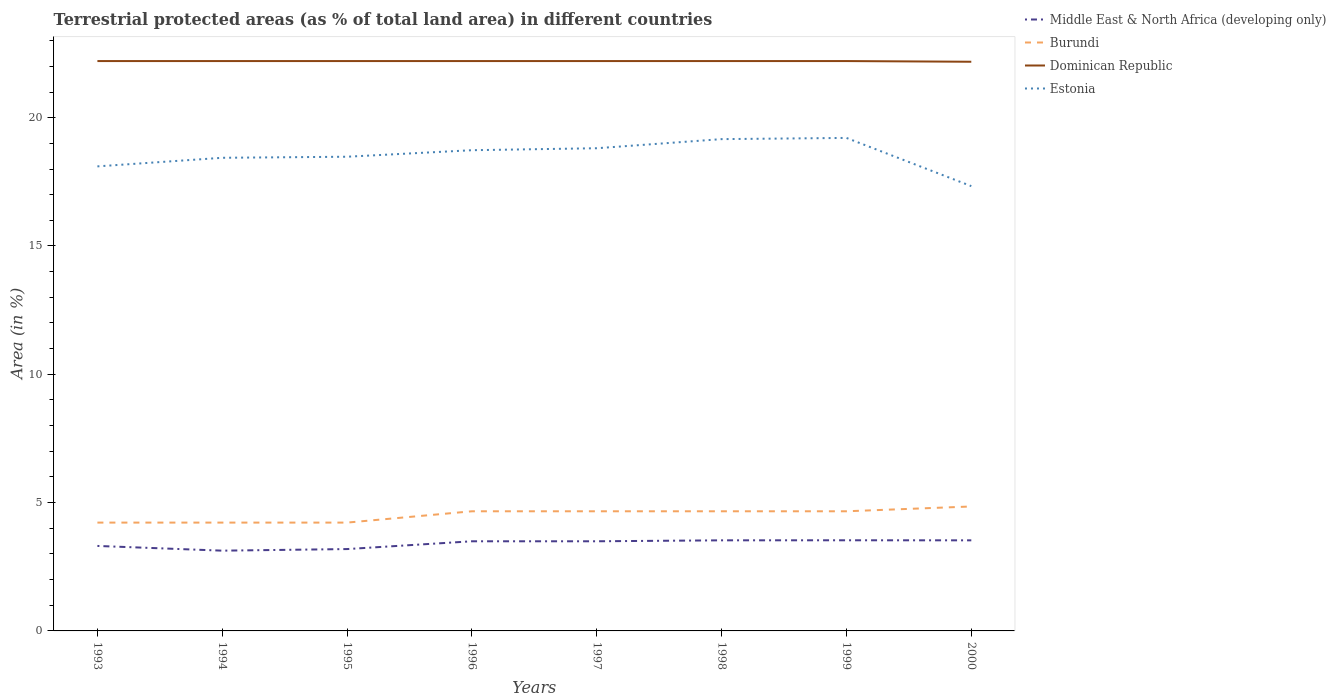How many different coloured lines are there?
Your answer should be compact. 4. Across all years, what is the maximum percentage of terrestrial protected land in Dominican Republic?
Offer a very short reply. 22.18. In which year was the percentage of terrestrial protected land in Dominican Republic maximum?
Ensure brevity in your answer.  2000. What is the total percentage of terrestrial protected land in Estonia in the graph?
Make the answer very short. 0.77. What is the difference between the highest and the second highest percentage of terrestrial protected land in Dominican Republic?
Ensure brevity in your answer.  0.03. What is the difference between the highest and the lowest percentage of terrestrial protected land in Middle East & North Africa (developing only)?
Make the answer very short. 5. How many lines are there?
Keep it short and to the point. 4. What is the difference between two consecutive major ticks on the Y-axis?
Offer a terse response. 5. Does the graph contain any zero values?
Your response must be concise. No. How many legend labels are there?
Keep it short and to the point. 4. What is the title of the graph?
Offer a terse response. Terrestrial protected areas (as % of total land area) in different countries. Does "Romania" appear as one of the legend labels in the graph?
Provide a short and direct response. No. What is the label or title of the Y-axis?
Give a very brief answer. Area (in %). What is the Area (in %) of Middle East & North Africa (developing only) in 1993?
Provide a short and direct response. 3.31. What is the Area (in %) of Burundi in 1993?
Offer a very short reply. 4.22. What is the Area (in %) in Dominican Republic in 1993?
Keep it short and to the point. 22.21. What is the Area (in %) in Estonia in 1993?
Offer a terse response. 18.1. What is the Area (in %) in Middle East & North Africa (developing only) in 1994?
Ensure brevity in your answer.  3.13. What is the Area (in %) in Burundi in 1994?
Your answer should be very brief. 4.22. What is the Area (in %) of Dominican Republic in 1994?
Your response must be concise. 22.21. What is the Area (in %) in Estonia in 1994?
Provide a succinct answer. 18.44. What is the Area (in %) of Middle East & North Africa (developing only) in 1995?
Your answer should be very brief. 3.19. What is the Area (in %) in Burundi in 1995?
Ensure brevity in your answer.  4.22. What is the Area (in %) in Dominican Republic in 1995?
Your answer should be compact. 22.21. What is the Area (in %) in Estonia in 1995?
Keep it short and to the point. 18.48. What is the Area (in %) of Middle East & North Africa (developing only) in 1996?
Give a very brief answer. 3.49. What is the Area (in %) of Burundi in 1996?
Your answer should be very brief. 4.66. What is the Area (in %) in Dominican Republic in 1996?
Provide a short and direct response. 22.21. What is the Area (in %) in Estonia in 1996?
Offer a very short reply. 18.73. What is the Area (in %) of Middle East & North Africa (developing only) in 1997?
Offer a very short reply. 3.49. What is the Area (in %) in Burundi in 1997?
Provide a short and direct response. 4.66. What is the Area (in %) in Dominican Republic in 1997?
Give a very brief answer. 22.21. What is the Area (in %) in Estonia in 1997?
Your answer should be very brief. 18.81. What is the Area (in %) of Middle East & North Africa (developing only) in 1998?
Offer a terse response. 3.53. What is the Area (in %) in Burundi in 1998?
Your answer should be very brief. 4.66. What is the Area (in %) in Dominican Republic in 1998?
Your response must be concise. 22.21. What is the Area (in %) of Estonia in 1998?
Ensure brevity in your answer.  19.16. What is the Area (in %) of Middle East & North Africa (developing only) in 1999?
Make the answer very short. 3.53. What is the Area (in %) in Burundi in 1999?
Offer a terse response. 4.66. What is the Area (in %) of Dominican Republic in 1999?
Provide a succinct answer. 22.21. What is the Area (in %) in Estonia in 1999?
Provide a short and direct response. 19.21. What is the Area (in %) in Middle East & North Africa (developing only) in 2000?
Provide a short and direct response. 3.53. What is the Area (in %) of Burundi in 2000?
Give a very brief answer. 4.85. What is the Area (in %) in Dominican Republic in 2000?
Make the answer very short. 22.18. What is the Area (in %) of Estonia in 2000?
Your answer should be compact. 17.33. Across all years, what is the maximum Area (in %) in Middle East & North Africa (developing only)?
Keep it short and to the point. 3.53. Across all years, what is the maximum Area (in %) in Burundi?
Give a very brief answer. 4.85. Across all years, what is the maximum Area (in %) of Dominican Republic?
Make the answer very short. 22.21. Across all years, what is the maximum Area (in %) in Estonia?
Your answer should be very brief. 19.21. Across all years, what is the minimum Area (in %) of Middle East & North Africa (developing only)?
Make the answer very short. 3.13. Across all years, what is the minimum Area (in %) of Burundi?
Offer a very short reply. 4.22. Across all years, what is the minimum Area (in %) in Dominican Republic?
Ensure brevity in your answer.  22.18. Across all years, what is the minimum Area (in %) in Estonia?
Your response must be concise. 17.33. What is the total Area (in %) in Middle East & North Africa (developing only) in the graph?
Your response must be concise. 27.21. What is the total Area (in %) in Burundi in the graph?
Make the answer very short. 36.16. What is the total Area (in %) of Dominican Republic in the graph?
Your answer should be compact. 177.63. What is the total Area (in %) of Estonia in the graph?
Ensure brevity in your answer.  148.27. What is the difference between the Area (in %) of Middle East & North Africa (developing only) in 1993 and that in 1994?
Your answer should be compact. 0.18. What is the difference between the Area (in %) of Burundi in 1993 and that in 1994?
Your response must be concise. 0. What is the difference between the Area (in %) of Dominican Republic in 1993 and that in 1994?
Make the answer very short. 0. What is the difference between the Area (in %) of Estonia in 1993 and that in 1994?
Ensure brevity in your answer.  -0.34. What is the difference between the Area (in %) of Middle East & North Africa (developing only) in 1993 and that in 1995?
Your answer should be very brief. 0.12. What is the difference between the Area (in %) of Estonia in 1993 and that in 1995?
Provide a succinct answer. -0.38. What is the difference between the Area (in %) of Middle East & North Africa (developing only) in 1993 and that in 1996?
Offer a very short reply. -0.18. What is the difference between the Area (in %) in Burundi in 1993 and that in 1996?
Your answer should be compact. -0.44. What is the difference between the Area (in %) in Estonia in 1993 and that in 1996?
Offer a terse response. -0.63. What is the difference between the Area (in %) in Middle East & North Africa (developing only) in 1993 and that in 1997?
Provide a short and direct response. -0.18. What is the difference between the Area (in %) of Burundi in 1993 and that in 1997?
Keep it short and to the point. -0.44. What is the difference between the Area (in %) in Estonia in 1993 and that in 1997?
Your response must be concise. -0.71. What is the difference between the Area (in %) in Middle East & North Africa (developing only) in 1993 and that in 1998?
Make the answer very short. -0.22. What is the difference between the Area (in %) of Burundi in 1993 and that in 1998?
Give a very brief answer. -0.44. What is the difference between the Area (in %) of Estonia in 1993 and that in 1998?
Provide a short and direct response. -1.06. What is the difference between the Area (in %) of Middle East & North Africa (developing only) in 1993 and that in 1999?
Keep it short and to the point. -0.22. What is the difference between the Area (in %) in Burundi in 1993 and that in 1999?
Your answer should be very brief. -0.44. What is the difference between the Area (in %) in Dominican Republic in 1993 and that in 1999?
Keep it short and to the point. 0. What is the difference between the Area (in %) in Estonia in 1993 and that in 1999?
Offer a very short reply. -1.11. What is the difference between the Area (in %) of Middle East & North Africa (developing only) in 1993 and that in 2000?
Make the answer very short. -0.22. What is the difference between the Area (in %) in Burundi in 1993 and that in 2000?
Keep it short and to the point. -0.63. What is the difference between the Area (in %) of Dominican Republic in 1993 and that in 2000?
Your answer should be very brief. 0.03. What is the difference between the Area (in %) in Estonia in 1993 and that in 2000?
Provide a short and direct response. 0.77. What is the difference between the Area (in %) in Middle East & North Africa (developing only) in 1994 and that in 1995?
Make the answer very short. -0.06. What is the difference between the Area (in %) in Burundi in 1994 and that in 1995?
Make the answer very short. 0. What is the difference between the Area (in %) in Dominican Republic in 1994 and that in 1995?
Your response must be concise. 0. What is the difference between the Area (in %) in Estonia in 1994 and that in 1995?
Your response must be concise. -0.04. What is the difference between the Area (in %) in Middle East & North Africa (developing only) in 1994 and that in 1996?
Keep it short and to the point. -0.37. What is the difference between the Area (in %) of Burundi in 1994 and that in 1996?
Your answer should be compact. -0.44. What is the difference between the Area (in %) in Dominican Republic in 1994 and that in 1996?
Give a very brief answer. 0. What is the difference between the Area (in %) in Estonia in 1994 and that in 1996?
Make the answer very short. -0.3. What is the difference between the Area (in %) of Middle East & North Africa (developing only) in 1994 and that in 1997?
Offer a terse response. -0.37. What is the difference between the Area (in %) in Burundi in 1994 and that in 1997?
Your answer should be very brief. -0.44. What is the difference between the Area (in %) in Estonia in 1994 and that in 1997?
Make the answer very short. -0.37. What is the difference between the Area (in %) of Middle East & North Africa (developing only) in 1994 and that in 1998?
Offer a terse response. -0.4. What is the difference between the Area (in %) of Burundi in 1994 and that in 1998?
Provide a succinct answer. -0.44. What is the difference between the Area (in %) in Dominican Republic in 1994 and that in 1998?
Keep it short and to the point. 0. What is the difference between the Area (in %) in Estonia in 1994 and that in 1998?
Offer a terse response. -0.73. What is the difference between the Area (in %) of Middle East & North Africa (developing only) in 1994 and that in 1999?
Make the answer very short. -0.4. What is the difference between the Area (in %) in Burundi in 1994 and that in 1999?
Your answer should be compact. -0.44. What is the difference between the Area (in %) in Estonia in 1994 and that in 1999?
Keep it short and to the point. -0.77. What is the difference between the Area (in %) of Middle East & North Africa (developing only) in 1994 and that in 2000?
Provide a succinct answer. -0.4. What is the difference between the Area (in %) in Burundi in 1994 and that in 2000?
Give a very brief answer. -0.63. What is the difference between the Area (in %) in Dominican Republic in 1994 and that in 2000?
Keep it short and to the point. 0.03. What is the difference between the Area (in %) in Estonia in 1994 and that in 2000?
Keep it short and to the point. 1.1. What is the difference between the Area (in %) of Middle East & North Africa (developing only) in 1995 and that in 1996?
Your response must be concise. -0.3. What is the difference between the Area (in %) in Burundi in 1995 and that in 1996?
Your response must be concise. -0.44. What is the difference between the Area (in %) of Dominican Republic in 1995 and that in 1996?
Give a very brief answer. 0. What is the difference between the Area (in %) in Estonia in 1995 and that in 1996?
Offer a very short reply. -0.25. What is the difference between the Area (in %) of Middle East & North Africa (developing only) in 1995 and that in 1997?
Your answer should be compact. -0.3. What is the difference between the Area (in %) of Burundi in 1995 and that in 1997?
Give a very brief answer. -0.44. What is the difference between the Area (in %) of Dominican Republic in 1995 and that in 1997?
Your response must be concise. 0. What is the difference between the Area (in %) in Estonia in 1995 and that in 1997?
Provide a succinct answer. -0.33. What is the difference between the Area (in %) in Middle East & North Africa (developing only) in 1995 and that in 1998?
Make the answer very short. -0.34. What is the difference between the Area (in %) in Burundi in 1995 and that in 1998?
Give a very brief answer. -0.44. What is the difference between the Area (in %) of Estonia in 1995 and that in 1998?
Your answer should be very brief. -0.69. What is the difference between the Area (in %) of Middle East & North Africa (developing only) in 1995 and that in 1999?
Your answer should be very brief. -0.34. What is the difference between the Area (in %) in Burundi in 1995 and that in 1999?
Your answer should be very brief. -0.44. What is the difference between the Area (in %) of Estonia in 1995 and that in 1999?
Your answer should be very brief. -0.73. What is the difference between the Area (in %) of Middle East & North Africa (developing only) in 1995 and that in 2000?
Keep it short and to the point. -0.34. What is the difference between the Area (in %) in Burundi in 1995 and that in 2000?
Keep it short and to the point. -0.63. What is the difference between the Area (in %) of Dominican Republic in 1995 and that in 2000?
Make the answer very short. 0.03. What is the difference between the Area (in %) of Estonia in 1995 and that in 2000?
Ensure brevity in your answer.  1.15. What is the difference between the Area (in %) of Middle East & North Africa (developing only) in 1996 and that in 1997?
Your response must be concise. -0. What is the difference between the Area (in %) in Estonia in 1996 and that in 1997?
Ensure brevity in your answer.  -0.08. What is the difference between the Area (in %) of Middle East & North Africa (developing only) in 1996 and that in 1998?
Make the answer very short. -0.04. What is the difference between the Area (in %) in Estonia in 1996 and that in 1998?
Give a very brief answer. -0.43. What is the difference between the Area (in %) in Middle East & North Africa (developing only) in 1996 and that in 1999?
Provide a short and direct response. -0.04. What is the difference between the Area (in %) in Burundi in 1996 and that in 1999?
Keep it short and to the point. 0. What is the difference between the Area (in %) of Estonia in 1996 and that in 1999?
Keep it short and to the point. -0.48. What is the difference between the Area (in %) of Middle East & North Africa (developing only) in 1996 and that in 2000?
Keep it short and to the point. -0.04. What is the difference between the Area (in %) of Burundi in 1996 and that in 2000?
Provide a short and direct response. -0.19. What is the difference between the Area (in %) of Dominican Republic in 1996 and that in 2000?
Give a very brief answer. 0.03. What is the difference between the Area (in %) of Middle East & North Africa (developing only) in 1997 and that in 1998?
Your response must be concise. -0.04. What is the difference between the Area (in %) of Estonia in 1997 and that in 1998?
Give a very brief answer. -0.35. What is the difference between the Area (in %) in Middle East & North Africa (developing only) in 1997 and that in 1999?
Offer a terse response. -0.04. What is the difference between the Area (in %) of Burundi in 1997 and that in 1999?
Your answer should be very brief. 0. What is the difference between the Area (in %) in Estonia in 1997 and that in 1999?
Your answer should be compact. -0.4. What is the difference between the Area (in %) in Middle East & North Africa (developing only) in 1997 and that in 2000?
Provide a succinct answer. -0.04. What is the difference between the Area (in %) in Burundi in 1997 and that in 2000?
Ensure brevity in your answer.  -0.19. What is the difference between the Area (in %) in Dominican Republic in 1997 and that in 2000?
Ensure brevity in your answer.  0.03. What is the difference between the Area (in %) in Estonia in 1997 and that in 2000?
Ensure brevity in your answer.  1.48. What is the difference between the Area (in %) of Middle East & North Africa (developing only) in 1998 and that in 1999?
Keep it short and to the point. -0. What is the difference between the Area (in %) of Dominican Republic in 1998 and that in 1999?
Your answer should be very brief. 0. What is the difference between the Area (in %) of Estonia in 1998 and that in 1999?
Offer a very short reply. -0.05. What is the difference between the Area (in %) of Middle East & North Africa (developing only) in 1998 and that in 2000?
Provide a short and direct response. 0. What is the difference between the Area (in %) in Burundi in 1998 and that in 2000?
Provide a succinct answer. -0.19. What is the difference between the Area (in %) in Dominican Republic in 1998 and that in 2000?
Give a very brief answer. 0.03. What is the difference between the Area (in %) in Estonia in 1998 and that in 2000?
Provide a succinct answer. 1.83. What is the difference between the Area (in %) of Middle East & North Africa (developing only) in 1999 and that in 2000?
Your answer should be very brief. 0. What is the difference between the Area (in %) of Burundi in 1999 and that in 2000?
Ensure brevity in your answer.  -0.19. What is the difference between the Area (in %) in Dominican Republic in 1999 and that in 2000?
Give a very brief answer. 0.03. What is the difference between the Area (in %) in Estonia in 1999 and that in 2000?
Provide a succinct answer. 1.88. What is the difference between the Area (in %) of Middle East & North Africa (developing only) in 1993 and the Area (in %) of Burundi in 1994?
Ensure brevity in your answer.  -0.91. What is the difference between the Area (in %) of Middle East & North Africa (developing only) in 1993 and the Area (in %) of Dominican Republic in 1994?
Give a very brief answer. -18.89. What is the difference between the Area (in %) in Middle East & North Africa (developing only) in 1993 and the Area (in %) in Estonia in 1994?
Provide a succinct answer. -15.13. What is the difference between the Area (in %) of Burundi in 1993 and the Area (in %) of Dominican Republic in 1994?
Ensure brevity in your answer.  -17.99. What is the difference between the Area (in %) of Burundi in 1993 and the Area (in %) of Estonia in 1994?
Your answer should be very brief. -14.22. What is the difference between the Area (in %) of Dominican Republic in 1993 and the Area (in %) of Estonia in 1994?
Provide a short and direct response. 3.77. What is the difference between the Area (in %) of Middle East & North Africa (developing only) in 1993 and the Area (in %) of Burundi in 1995?
Ensure brevity in your answer.  -0.91. What is the difference between the Area (in %) of Middle East & North Africa (developing only) in 1993 and the Area (in %) of Dominican Republic in 1995?
Give a very brief answer. -18.89. What is the difference between the Area (in %) of Middle East & North Africa (developing only) in 1993 and the Area (in %) of Estonia in 1995?
Offer a very short reply. -15.17. What is the difference between the Area (in %) of Burundi in 1993 and the Area (in %) of Dominican Republic in 1995?
Make the answer very short. -17.99. What is the difference between the Area (in %) of Burundi in 1993 and the Area (in %) of Estonia in 1995?
Provide a short and direct response. -14.26. What is the difference between the Area (in %) in Dominican Republic in 1993 and the Area (in %) in Estonia in 1995?
Make the answer very short. 3.73. What is the difference between the Area (in %) of Middle East & North Africa (developing only) in 1993 and the Area (in %) of Burundi in 1996?
Your answer should be very brief. -1.35. What is the difference between the Area (in %) in Middle East & North Africa (developing only) in 1993 and the Area (in %) in Dominican Republic in 1996?
Provide a succinct answer. -18.89. What is the difference between the Area (in %) in Middle East & North Africa (developing only) in 1993 and the Area (in %) in Estonia in 1996?
Offer a terse response. -15.42. What is the difference between the Area (in %) of Burundi in 1993 and the Area (in %) of Dominican Republic in 1996?
Keep it short and to the point. -17.99. What is the difference between the Area (in %) of Burundi in 1993 and the Area (in %) of Estonia in 1996?
Your answer should be compact. -14.51. What is the difference between the Area (in %) in Dominican Republic in 1993 and the Area (in %) in Estonia in 1996?
Offer a very short reply. 3.47. What is the difference between the Area (in %) in Middle East & North Africa (developing only) in 1993 and the Area (in %) in Burundi in 1997?
Provide a succinct answer. -1.35. What is the difference between the Area (in %) of Middle East & North Africa (developing only) in 1993 and the Area (in %) of Dominican Republic in 1997?
Provide a short and direct response. -18.89. What is the difference between the Area (in %) in Middle East & North Africa (developing only) in 1993 and the Area (in %) in Estonia in 1997?
Make the answer very short. -15.5. What is the difference between the Area (in %) of Burundi in 1993 and the Area (in %) of Dominican Republic in 1997?
Give a very brief answer. -17.99. What is the difference between the Area (in %) of Burundi in 1993 and the Area (in %) of Estonia in 1997?
Make the answer very short. -14.59. What is the difference between the Area (in %) of Dominican Republic in 1993 and the Area (in %) of Estonia in 1997?
Your answer should be very brief. 3.4. What is the difference between the Area (in %) of Middle East & North Africa (developing only) in 1993 and the Area (in %) of Burundi in 1998?
Provide a short and direct response. -1.35. What is the difference between the Area (in %) in Middle East & North Africa (developing only) in 1993 and the Area (in %) in Dominican Republic in 1998?
Your response must be concise. -18.89. What is the difference between the Area (in %) in Middle East & North Africa (developing only) in 1993 and the Area (in %) in Estonia in 1998?
Offer a terse response. -15.85. What is the difference between the Area (in %) of Burundi in 1993 and the Area (in %) of Dominican Republic in 1998?
Offer a terse response. -17.99. What is the difference between the Area (in %) in Burundi in 1993 and the Area (in %) in Estonia in 1998?
Your answer should be compact. -14.94. What is the difference between the Area (in %) in Dominican Republic in 1993 and the Area (in %) in Estonia in 1998?
Give a very brief answer. 3.04. What is the difference between the Area (in %) in Middle East & North Africa (developing only) in 1993 and the Area (in %) in Burundi in 1999?
Your answer should be compact. -1.35. What is the difference between the Area (in %) of Middle East & North Africa (developing only) in 1993 and the Area (in %) of Dominican Republic in 1999?
Your answer should be very brief. -18.89. What is the difference between the Area (in %) of Middle East & North Africa (developing only) in 1993 and the Area (in %) of Estonia in 1999?
Make the answer very short. -15.9. What is the difference between the Area (in %) of Burundi in 1993 and the Area (in %) of Dominican Republic in 1999?
Give a very brief answer. -17.99. What is the difference between the Area (in %) in Burundi in 1993 and the Area (in %) in Estonia in 1999?
Offer a very short reply. -14.99. What is the difference between the Area (in %) of Dominican Republic in 1993 and the Area (in %) of Estonia in 1999?
Offer a terse response. 3. What is the difference between the Area (in %) of Middle East & North Africa (developing only) in 1993 and the Area (in %) of Burundi in 2000?
Your answer should be compact. -1.54. What is the difference between the Area (in %) in Middle East & North Africa (developing only) in 1993 and the Area (in %) in Dominican Republic in 2000?
Offer a very short reply. -18.87. What is the difference between the Area (in %) in Middle East & North Africa (developing only) in 1993 and the Area (in %) in Estonia in 2000?
Provide a short and direct response. -14.02. What is the difference between the Area (in %) in Burundi in 1993 and the Area (in %) in Dominican Republic in 2000?
Ensure brevity in your answer.  -17.96. What is the difference between the Area (in %) of Burundi in 1993 and the Area (in %) of Estonia in 2000?
Provide a succinct answer. -13.11. What is the difference between the Area (in %) of Dominican Republic in 1993 and the Area (in %) of Estonia in 2000?
Ensure brevity in your answer.  4.87. What is the difference between the Area (in %) in Middle East & North Africa (developing only) in 1994 and the Area (in %) in Burundi in 1995?
Give a very brief answer. -1.09. What is the difference between the Area (in %) in Middle East & North Africa (developing only) in 1994 and the Area (in %) in Dominican Republic in 1995?
Your answer should be very brief. -19.08. What is the difference between the Area (in %) of Middle East & North Africa (developing only) in 1994 and the Area (in %) of Estonia in 1995?
Give a very brief answer. -15.35. What is the difference between the Area (in %) in Burundi in 1994 and the Area (in %) in Dominican Republic in 1995?
Your response must be concise. -17.99. What is the difference between the Area (in %) of Burundi in 1994 and the Area (in %) of Estonia in 1995?
Keep it short and to the point. -14.26. What is the difference between the Area (in %) in Dominican Republic in 1994 and the Area (in %) in Estonia in 1995?
Your answer should be compact. 3.73. What is the difference between the Area (in %) in Middle East & North Africa (developing only) in 1994 and the Area (in %) in Burundi in 1996?
Ensure brevity in your answer.  -1.53. What is the difference between the Area (in %) in Middle East & North Africa (developing only) in 1994 and the Area (in %) in Dominican Republic in 1996?
Your answer should be very brief. -19.08. What is the difference between the Area (in %) in Middle East & North Africa (developing only) in 1994 and the Area (in %) in Estonia in 1996?
Your response must be concise. -15.6. What is the difference between the Area (in %) of Burundi in 1994 and the Area (in %) of Dominican Republic in 1996?
Offer a very short reply. -17.99. What is the difference between the Area (in %) in Burundi in 1994 and the Area (in %) in Estonia in 1996?
Give a very brief answer. -14.51. What is the difference between the Area (in %) in Dominican Republic in 1994 and the Area (in %) in Estonia in 1996?
Offer a very short reply. 3.47. What is the difference between the Area (in %) of Middle East & North Africa (developing only) in 1994 and the Area (in %) of Burundi in 1997?
Ensure brevity in your answer.  -1.53. What is the difference between the Area (in %) of Middle East & North Africa (developing only) in 1994 and the Area (in %) of Dominican Republic in 1997?
Your answer should be very brief. -19.08. What is the difference between the Area (in %) in Middle East & North Africa (developing only) in 1994 and the Area (in %) in Estonia in 1997?
Offer a terse response. -15.68. What is the difference between the Area (in %) in Burundi in 1994 and the Area (in %) in Dominican Republic in 1997?
Your answer should be compact. -17.99. What is the difference between the Area (in %) in Burundi in 1994 and the Area (in %) in Estonia in 1997?
Offer a terse response. -14.59. What is the difference between the Area (in %) of Dominican Republic in 1994 and the Area (in %) of Estonia in 1997?
Keep it short and to the point. 3.4. What is the difference between the Area (in %) in Middle East & North Africa (developing only) in 1994 and the Area (in %) in Burundi in 1998?
Make the answer very short. -1.53. What is the difference between the Area (in %) in Middle East & North Africa (developing only) in 1994 and the Area (in %) in Dominican Republic in 1998?
Give a very brief answer. -19.08. What is the difference between the Area (in %) in Middle East & North Africa (developing only) in 1994 and the Area (in %) in Estonia in 1998?
Provide a short and direct response. -16.04. What is the difference between the Area (in %) in Burundi in 1994 and the Area (in %) in Dominican Republic in 1998?
Ensure brevity in your answer.  -17.99. What is the difference between the Area (in %) in Burundi in 1994 and the Area (in %) in Estonia in 1998?
Your answer should be very brief. -14.94. What is the difference between the Area (in %) in Dominican Republic in 1994 and the Area (in %) in Estonia in 1998?
Keep it short and to the point. 3.04. What is the difference between the Area (in %) of Middle East & North Africa (developing only) in 1994 and the Area (in %) of Burundi in 1999?
Give a very brief answer. -1.53. What is the difference between the Area (in %) in Middle East & North Africa (developing only) in 1994 and the Area (in %) in Dominican Republic in 1999?
Give a very brief answer. -19.08. What is the difference between the Area (in %) in Middle East & North Africa (developing only) in 1994 and the Area (in %) in Estonia in 1999?
Offer a terse response. -16.08. What is the difference between the Area (in %) of Burundi in 1994 and the Area (in %) of Dominican Republic in 1999?
Provide a short and direct response. -17.99. What is the difference between the Area (in %) in Burundi in 1994 and the Area (in %) in Estonia in 1999?
Your response must be concise. -14.99. What is the difference between the Area (in %) in Dominican Republic in 1994 and the Area (in %) in Estonia in 1999?
Offer a very short reply. 3. What is the difference between the Area (in %) of Middle East & North Africa (developing only) in 1994 and the Area (in %) of Burundi in 2000?
Your answer should be compact. -1.72. What is the difference between the Area (in %) of Middle East & North Africa (developing only) in 1994 and the Area (in %) of Dominican Republic in 2000?
Your answer should be very brief. -19.05. What is the difference between the Area (in %) in Middle East & North Africa (developing only) in 1994 and the Area (in %) in Estonia in 2000?
Give a very brief answer. -14.21. What is the difference between the Area (in %) in Burundi in 1994 and the Area (in %) in Dominican Republic in 2000?
Your response must be concise. -17.96. What is the difference between the Area (in %) of Burundi in 1994 and the Area (in %) of Estonia in 2000?
Provide a succinct answer. -13.11. What is the difference between the Area (in %) of Dominican Republic in 1994 and the Area (in %) of Estonia in 2000?
Give a very brief answer. 4.87. What is the difference between the Area (in %) of Middle East & North Africa (developing only) in 1995 and the Area (in %) of Burundi in 1996?
Offer a very short reply. -1.47. What is the difference between the Area (in %) of Middle East & North Africa (developing only) in 1995 and the Area (in %) of Dominican Republic in 1996?
Make the answer very short. -19.02. What is the difference between the Area (in %) of Middle East & North Africa (developing only) in 1995 and the Area (in %) of Estonia in 1996?
Make the answer very short. -15.54. What is the difference between the Area (in %) in Burundi in 1995 and the Area (in %) in Dominican Republic in 1996?
Your answer should be very brief. -17.99. What is the difference between the Area (in %) of Burundi in 1995 and the Area (in %) of Estonia in 1996?
Your response must be concise. -14.51. What is the difference between the Area (in %) of Dominican Republic in 1995 and the Area (in %) of Estonia in 1996?
Make the answer very short. 3.47. What is the difference between the Area (in %) in Middle East & North Africa (developing only) in 1995 and the Area (in %) in Burundi in 1997?
Provide a succinct answer. -1.47. What is the difference between the Area (in %) of Middle East & North Africa (developing only) in 1995 and the Area (in %) of Dominican Republic in 1997?
Keep it short and to the point. -19.02. What is the difference between the Area (in %) of Middle East & North Africa (developing only) in 1995 and the Area (in %) of Estonia in 1997?
Your response must be concise. -15.62. What is the difference between the Area (in %) of Burundi in 1995 and the Area (in %) of Dominican Republic in 1997?
Your answer should be very brief. -17.99. What is the difference between the Area (in %) of Burundi in 1995 and the Area (in %) of Estonia in 1997?
Give a very brief answer. -14.59. What is the difference between the Area (in %) of Dominican Republic in 1995 and the Area (in %) of Estonia in 1997?
Give a very brief answer. 3.4. What is the difference between the Area (in %) of Middle East & North Africa (developing only) in 1995 and the Area (in %) of Burundi in 1998?
Provide a short and direct response. -1.47. What is the difference between the Area (in %) in Middle East & North Africa (developing only) in 1995 and the Area (in %) in Dominican Republic in 1998?
Provide a short and direct response. -19.02. What is the difference between the Area (in %) in Middle East & North Africa (developing only) in 1995 and the Area (in %) in Estonia in 1998?
Your answer should be very brief. -15.97. What is the difference between the Area (in %) in Burundi in 1995 and the Area (in %) in Dominican Republic in 1998?
Ensure brevity in your answer.  -17.99. What is the difference between the Area (in %) of Burundi in 1995 and the Area (in %) of Estonia in 1998?
Offer a terse response. -14.94. What is the difference between the Area (in %) of Dominican Republic in 1995 and the Area (in %) of Estonia in 1998?
Your answer should be very brief. 3.04. What is the difference between the Area (in %) of Middle East & North Africa (developing only) in 1995 and the Area (in %) of Burundi in 1999?
Your answer should be compact. -1.47. What is the difference between the Area (in %) in Middle East & North Africa (developing only) in 1995 and the Area (in %) in Dominican Republic in 1999?
Make the answer very short. -19.02. What is the difference between the Area (in %) in Middle East & North Africa (developing only) in 1995 and the Area (in %) in Estonia in 1999?
Offer a terse response. -16.02. What is the difference between the Area (in %) of Burundi in 1995 and the Area (in %) of Dominican Republic in 1999?
Offer a very short reply. -17.99. What is the difference between the Area (in %) in Burundi in 1995 and the Area (in %) in Estonia in 1999?
Make the answer very short. -14.99. What is the difference between the Area (in %) of Dominican Republic in 1995 and the Area (in %) of Estonia in 1999?
Your answer should be compact. 3. What is the difference between the Area (in %) in Middle East & North Africa (developing only) in 1995 and the Area (in %) in Burundi in 2000?
Ensure brevity in your answer.  -1.66. What is the difference between the Area (in %) in Middle East & North Africa (developing only) in 1995 and the Area (in %) in Dominican Republic in 2000?
Your response must be concise. -18.99. What is the difference between the Area (in %) in Middle East & North Africa (developing only) in 1995 and the Area (in %) in Estonia in 2000?
Provide a succinct answer. -14.14. What is the difference between the Area (in %) of Burundi in 1995 and the Area (in %) of Dominican Republic in 2000?
Make the answer very short. -17.96. What is the difference between the Area (in %) of Burundi in 1995 and the Area (in %) of Estonia in 2000?
Your answer should be compact. -13.11. What is the difference between the Area (in %) of Dominican Republic in 1995 and the Area (in %) of Estonia in 2000?
Provide a succinct answer. 4.87. What is the difference between the Area (in %) of Middle East & North Africa (developing only) in 1996 and the Area (in %) of Burundi in 1997?
Offer a very short reply. -1.17. What is the difference between the Area (in %) in Middle East & North Africa (developing only) in 1996 and the Area (in %) in Dominican Republic in 1997?
Keep it short and to the point. -18.71. What is the difference between the Area (in %) in Middle East & North Africa (developing only) in 1996 and the Area (in %) in Estonia in 1997?
Offer a terse response. -15.32. What is the difference between the Area (in %) in Burundi in 1996 and the Area (in %) in Dominican Republic in 1997?
Provide a short and direct response. -17.54. What is the difference between the Area (in %) in Burundi in 1996 and the Area (in %) in Estonia in 1997?
Offer a terse response. -14.15. What is the difference between the Area (in %) of Dominican Republic in 1996 and the Area (in %) of Estonia in 1997?
Provide a succinct answer. 3.4. What is the difference between the Area (in %) of Middle East & North Africa (developing only) in 1996 and the Area (in %) of Burundi in 1998?
Give a very brief answer. -1.17. What is the difference between the Area (in %) of Middle East & North Africa (developing only) in 1996 and the Area (in %) of Dominican Republic in 1998?
Offer a terse response. -18.71. What is the difference between the Area (in %) of Middle East & North Africa (developing only) in 1996 and the Area (in %) of Estonia in 1998?
Make the answer very short. -15.67. What is the difference between the Area (in %) of Burundi in 1996 and the Area (in %) of Dominican Republic in 1998?
Your answer should be very brief. -17.54. What is the difference between the Area (in %) of Burundi in 1996 and the Area (in %) of Estonia in 1998?
Make the answer very short. -14.5. What is the difference between the Area (in %) in Dominican Republic in 1996 and the Area (in %) in Estonia in 1998?
Provide a succinct answer. 3.04. What is the difference between the Area (in %) in Middle East & North Africa (developing only) in 1996 and the Area (in %) in Burundi in 1999?
Offer a terse response. -1.17. What is the difference between the Area (in %) of Middle East & North Africa (developing only) in 1996 and the Area (in %) of Dominican Republic in 1999?
Ensure brevity in your answer.  -18.71. What is the difference between the Area (in %) in Middle East & North Africa (developing only) in 1996 and the Area (in %) in Estonia in 1999?
Offer a terse response. -15.72. What is the difference between the Area (in %) of Burundi in 1996 and the Area (in %) of Dominican Republic in 1999?
Provide a succinct answer. -17.54. What is the difference between the Area (in %) in Burundi in 1996 and the Area (in %) in Estonia in 1999?
Provide a short and direct response. -14.55. What is the difference between the Area (in %) of Dominican Republic in 1996 and the Area (in %) of Estonia in 1999?
Give a very brief answer. 3. What is the difference between the Area (in %) in Middle East & North Africa (developing only) in 1996 and the Area (in %) in Burundi in 2000?
Give a very brief answer. -1.36. What is the difference between the Area (in %) of Middle East & North Africa (developing only) in 1996 and the Area (in %) of Dominican Republic in 2000?
Your answer should be compact. -18.69. What is the difference between the Area (in %) of Middle East & North Africa (developing only) in 1996 and the Area (in %) of Estonia in 2000?
Your answer should be very brief. -13.84. What is the difference between the Area (in %) in Burundi in 1996 and the Area (in %) in Dominican Republic in 2000?
Make the answer very short. -17.52. What is the difference between the Area (in %) in Burundi in 1996 and the Area (in %) in Estonia in 2000?
Your answer should be compact. -12.67. What is the difference between the Area (in %) of Dominican Republic in 1996 and the Area (in %) of Estonia in 2000?
Your answer should be very brief. 4.87. What is the difference between the Area (in %) of Middle East & North Africa (developing only) in 1997 and the Area (in %) of Burundi in 1998?
Your response must be concise. -1.17. What is the difference between the Area (in %) of Middle East & North Africa (developing only) in 1997 and the Area (in %) of Dominican Republic in 1998?
Ensure brevity in your answer.  -18.71. What is the difference between the Area (in %) of Middle East & North Africa (developing only) in 1997 and the Area (in %) of Estonia in 1998?
Make the answer very short. -15.67. What is the difference between the Area (in %) of Burundi in 1997 and the Area (in %) of Dominican Republic in 1998?
Make the answer very short. -17.54. What is the difference between the Area (in %) in Burundi in 1997 and the Area (in %) in Estonia in 1998?
Keep it short and to the point. -14.5. What is the difference between the Area (in %) in Dominican Republic in 1997 and the Area (in %) in Estonia in 1998?
Keep it short and to the point. 3.04. What is the difference between the Area (in %) in Middle East & North Africa (developing only) in 1997 and the Area (in %) in Burundi in 1999?
Your response must be concise. -1.17. What is the difference between the Area (in %) in Middle East & North Africa (developing only) in 1997 and the Area (in %) in Dominican Republic in 1999?
Give a very brief answer. -18.71. What is the difference between the Area (in %) in Middle East & North Africa (developing only) in 1997 and the Area (in %) in Estonia in 1999?
Provide a succinct answer. -15.72. What is the difference between the Area (in %) of Burundi in 1997 and the Area (in %) of Dominican Republic in 1999?
Provide a succinct answer. -17.54. What is the difference between the Area (in %) of Burundi in 1997 and the Area (in %) of Estonia in 1999?
Make the answer very short. -14.55. What is the difference between the Area (in %) in Dominican Republic in 1997 and the Area (in %) in Estonia in 1999?
Your response must be concise. 3. What is the difference between the Area (in %) of Middle East & North Africa (developing only) in 1997 and the Area (in %) of Burundi in 2000?
Give a very brief answer. -1.36. What is the difference between the Area (in %) in Middle East & North Africa (developing only) in 1997 and the Area (in %) in Dominican Republic in 2000?
Ensure brevity in your answer.  -18.69. What is the difference between the Area (in %) of Middle East & North Africa (developing only) in 1997 and the Area (in %) of Estonia in 2000?
Your answer should be very brief. -13.84. What is the difference between the Area (in %) of Burundi in 1997 and the Area (in %) of Dominican Republic in 2000?
Provide a succinct answer. -17.52. What is the difference between the Area (in %) in Burundi in 1997 and the Area (in %) in Estonia in 2000?
Your answer should be compact. -12.67. What is the difference between the Area (in %) of Dominican Republic in 1997 and the Area (in %) of Estonia in 2000?
Offer a very short reply. 4.87. What is the difference between the Area (in %) in Middle East & North Africa (developing only) in 1998 and the Area (in %) in Burundi in 1999?
Offer a very short reply. -1.13. What is the difference between the Area (in %) in Middle East & North Africa (developing only) in 1998 and the Area (in %) in Dominican Republic in 1999?
Your answer should be compact. -18.68. What is the difference between the Area (in %) of Middle East & North Africa (developing only) in 1998 and the Area (in %) of Estonia in 1999?
Make the answer very short. -15.68. What is the difference between the Area (in %) in Burundi in 1998 and the Area (in %) in Dominican Republic in 1999?
Offer a very short reply. -17.54. What is the difference between the Area (in %) of Burundi in 1998 and the Area (in %) of Estonia in 1999?
Offer a very short reply. -14.55. What is the difference between the Area (in %) of Dominican Republic in 1998 and the Area (in %) of Estonia in 1999?
Ensure brevity in your answer.  3. What is the difference between the Area (in %) of Middle East & North Africa (developing only) in 1998 and the Area (in %) of Burundi in 2000?
Make the answer very short. -1.32. What is the difference between the Area (in %) in Middle East & North Africa (developing only) in 1998 and the Area (in %) in Dominican Republic in 2000?
Make the answer very short. -18.65. What is the difference between the Area (in %) of Middle East & North Africa (developing only) in 1998 and the Area (in %) of Estonia in 2000?
Give a very brief answer. -13.8. What is the difference between the Area (in %) of Burundi in 1998 and the Area (in %) of Dominican Republic in 2000?
Offer a terse response. -17.52. What is the difference between the Area (in %) in Burundi in 1998 and the Area (in %) in Estonia in 2000?
Your answer should be compact. -12.67. What is the difference between the Area (in %) in Dominican Republic in 1998 and the Area (in %) in Estonia in 2000?
Offer a very short reply. 4.87. What is the difference between the Area (in %) of Middle East & North Africa (developing only) in 1999 and the Area (in %) of Burundi in 2000?
Offer a very short reply. -1.32. What is the difference between the Area (in %) of Middle East & North Africa (developing only) in 1999 and the Area (in %) of Dominican Republic in 2000?
Keep it short and to the point. -18.65. What is the difference between the Area (in %) of Middle East & North Africa (developing only) in 1999 and the Area (in %) of Estonia in 2000?
Give a very brief answer. -13.8. What is the difference between the Area (in %) of Burundi in 1999 and the Area (in %) of Dominican Republic in 2000?
Give a very brief answer. -17.52. What is the difference between the Area (in %) of Burundi in 1999 and the Area (in %) of Estonia in 2000?
Offer a terse response. -12.67. What is the difference between the Area (in %) in Dominican Republic in 1999 and the Area (in %) in Estonia in 2000?
Give a very brief answer. 4.87. What is the average Area (in %) of Middle East & North Africa (developing only) per year?
Provide a succinct answer. 3.4. What is the average Area (in %) in Burundi per year?
Offer a terse response. 4.52. What is the average Area (in %) in Dominican Republic per year?
Keep it short and to the point. 22.2. What is the average Area (in %) in Estonia per year?
Provide a succinct answer. 18.53. In the year 1993, what is the difference between the Area (in %) in Middle East & North Africa (developing only) and Area (in %) in Burundi?
Offer a terse response. -0.91. In the year 1993, what is the difference between the Area (in %) of Middle East & North Africa (developing only) and Area (in %) of Dominican Republic?
Make the answer very short. -18.89. In the year 1993, what is the difference between the Area (in %) of Middle East & North Africa (developing only) and Area (in %) of Estonia?
Your answer should be compact. -14.79. In the year 1993, what is the difference between the Area (in %) in Burundi and Area (in %) in Dominican Republic?
Your answer should be very brief. -17.99. In the year 1993, what is the difference between the Area (in %) of Burundi and Area (in %) of Estonia?
Keep it short and to the point. -13.88. In the year 1993, what is the difference between the Area (in %) of Dominican Republic and Area (in %) of Estonia?
Provide a short and direct response. 4.1. In the year 1994, what is the difference between the Area (in %) of Middle East & North Africa (developing only) and Area (in %) of Burundi?
Provide a succinct answer. -1.09. In the year 1994, what is the difference between the Area (in %) in Middle East & North Africa (developing only) and Area (in %) in Dominican Republic?
Provide a short and direct response. -19.08. In the year 1994, what is the difference between the Area (in %) in Middle East & North Africa (developing only) and Area (in %) in Estonia?
Make the answer very short. -15.31. In the year 1994, what is the difference between the Area (in %) in Burundi and Area (in %) in Dominican Republic?
Your response must be concise. -17.99. In the year 1994, what is the difference between the Area (in %) in Burundi and Area (in %) in Estonia?
Keep it short and to the point. -14.22. In the year 1994, what is the difference between the Area (in %) in Dominican Republic and Area (in %) in Estonia?
Give a very brief answer. 3.77. In the year 1995, what is the difference between the Area (in %) in Middle East & North Africa (developing only) and Area (in %) in Burundi?
Ensure brevity in your answer.  -1.03. In the year 1995, what is the difference between the Area (in %) in Middle East & North Africa (developing only) and Area (in %) in Dominican Republic?
Your response must be concise. -19.02. In the year 1995, what is the difference between the Area (in %) in Middle East & North Africa (developing only) and Area (in %) in Estonia?
Offer a very short reply. -15.29. In the year 1995, what is the difference between the Area (in %) of Burundi and Area (in %) of Dominican Republic?
Give a very brief answer. -17.99. In the year 1995, what is the difference between the Area (in %) of Burundi and Area (in %) of Estonia?
Give a very brief answer. -14.26. In the year 1995, what is the difference between the Area (in %) of Dominican Republic and Area (in %) of Estonia?
Offer a terse response. 3.73. In the year 1996, what is the difference between the Area (in %) of Middle East & North Africa (developing only) and Area (in %) of Burundi?
Offer a terse response. -1.17. In the year 1996, what is the difference between the Area (in %) of Middle East & North Africa (developing only) and Area (in %) of Dominican Republic?
Your answer should be very brief. -18.71. In the year 1996, what is the difference between the Area (in %) of Middle East & North Africa (developing only) and Area (in %) of Estonia?
Make the answer very short. -15.24. In the year 1996, what is the difference between the Area (in %) of Burundi and Area (in %) of Dominican Republic?
Make the answer very short. -17.54. In the year 1996, what is the difference between the Area (in %) of Burundi and Area (in %) of Estonia?
Provide a short and direct response. -14.07. In the year 1996, what is the difference between the Area (in %) in Dominican Republic and Area (in %) in Estonia?
Offer a terse response. 3.47. In the year 1997, what is the difference between the Area (in %) in Middle East & North Africa (developing only) and Area (in %) in Burundi?
Give a very brief answer. -1.17. In the year 1997, what is the difference between the Area (in %) in Middle East & North Africa (developing only) and Area (in %) in Dominican Republic?
Make the answer very short. -18.71. In the year 1997, what is the difference between the Area (in %) of Middle East & North Africa (developing only) and Area (in %) of Estonia?
Provide a succinct answer. -15.32. In the year 1997, what is the difference between the Area (in %) of Burundi and Area (in %) of Dominican Republic?
Make the answer very short. -17.54. In the year 1997, what is the difference between the Area (in %) of Burundi and Area (in %) of Estonia?
Offer a very short reply. -14.15. In the year 1997, what is the difference between the Area (in %) of Dominican Republic and Area (in %) of Estonia?
Offer a very short reply. 3.4. In the year 1998, what is the difference between the Area (in %) in Middle East & North Africa (developing only) and Area (in %) in Burundi?
Ensure brevity in your answer.  -1.13. In the year 1998, what is the difference between the Area (in %) in Middle East & North Africa (developing only) and Area (in %) in Dominican Republic?
Offer a terse response. -18.68. In the year 1998, what is the difference between the Area (in %) of Middle East & North Africa (developing only) and Area (in %) of Estonia?
Ensure brevity in your answer.  -15.63. In the year 1998, what is the difference between the Area (in %) of Burundi and Area (in %) of Dominican Republic?
Your response must be concise. -17.54. In the year 1998, what is the difference between the Area (in %) in Burundi and Area (in %) in Estonia?
Provide a succinct answer. -14.5. In the year 1998, what is the difference between the Area (in %) in Dominican Republic and Area (in %) in Estonia?
Make the answer very short. 3.04. In the year 1999, what is the difference between the Area (in %) in Middle East & North Africa (developing only) and Area (in %) in Burundi?
Keep it short and to the point. -1.13. In the year 1999, what is the difference between the Area (in %) in Middle East & North Africa (developing only) and Area (in %) in Dominican Republic?
Keep it short and to the point. -18.67. In the year 1999, what is the difference between the Area (in %) in Middle East & North Africa (developing only) and Area (in %) in Estonia?
Provide a succinct answer. -15.68. In the year 1999, what is the difference between the Area (in %) in Burundi and Area (in %) in Dominican Republic?
Ensure brevity in your answer.  -17.54. In the year 1999, what is the difference between the Area (in %) of Burundi and Area (in %) of Estonia?
Your response must be concise. -14.55. In the year 1999, what is the difference between the Area (in %) in Dominican Republic and Area (in %) in Estonia?
Your answer should be very brief. 3. In the year 2000, what is the difference between the Area (in %) in Middle East & North Africa (developing only) and Area (in %) in Burundi?
Make the answer very short. -1.32. In the year 2000, what is the difference between the Area (in %) of Middle East & North Africa (developing only) and Area (in %) of Dominican Republic?
Provide a short and direct response. -18.65. In the year 2000, what is the difference between the Area (in %) of Middle East & North Africa (developing only) and Area (in %) of Estonia?
Offer a terse response. -13.8. In the year 2000, what is the difference between the Area (in %) of Burundi and Area (in %) of Dominican Republic?
Provide a succinct answer. -17.33. In the year 2000, what is the difference between the Area (in %) in Burundi and Area (in %) in Estonia?
Your answer should be very brief. -12.48. In the year 2000, what is the difference between the Area (in %) of Dominican Republic and Area (in %) of Estonia?
Give a very brief answer. 4.85. What is the ratio of the Area (in %) of Middle East & North Africa (developing only) in 1993 to that in 1994?
Give a very brief answer. 1.06. What is the ratio of the Area (in %) in Estonia in 1993 to that in 1994?
Your response must be concise. 0.98. What is the ratio of the Area (in %) in Middle East & North Africa (developing only) in 1993 to that in 1995?
Offer a terse response. 1.04. What is the ratio of the Area (in %) of Burundi in 1993 to that in 1995?
Your response must be concise. 1. What is the ratio of the Area (in %) in Dominican Republic in 1993 to that in 1995?
Your answer should be compact. 1. What is the ratio of the Area (in %) in Estonia in 1993 to that in 1995?
Offer a terse response. 0.98. What is the ratio of the Area (in %) of Middle East & North Africa (developing only) in 1993 to that in 1996?
Offer a very short reply. 0.95. What is the ratio of the Area (in %) in Burundi in 1993 to that in 1996?
Keep it short and to the point. 0.91. What is the ratio of the Area (in %) in Estonia in 1993 to that in 1996?
Offer a very short reply. 0.97. What is the ratio of the Area (in %) in Middle East & North Africa (developing only) in 1993 to that in 1997?
Offer a very short reply. 0.95. What is the ratio of the Area (in %) of Burundi in 1993 to that in 1997?
Offer a very short reply. 0.91. What is the ratio of the Area (in %) of Dominican Republic in 1993 to that in 1997?
Your answer should be very brief. 1. What is the ratio of the Area (in %) of Estonia in 1993 to that in 1997?
Ensure brevity in your answer.  0.96. What is the ratio of the Area (in %) of Middle East & North Africa (developing only) in 1993 to that in 1998?
Provide a short and direct response. 0.94. What is the ratio of the Area (in %) in Burundi in 1993 to that in 1998?
Provide a short and direct response. 0.91. What is the ratio of the Area (in %) of Dominican Republic in 1993 to that in 1998?
Offer a very short reply. 1. What is the ratio of the Area (in %) in Estonia in 1993 to that in 1998?
Your response must be concise. 0.94. What is the ratio of the Area (in %) in Burundi in 1993 to that in 1999?
Your response must be concise. 0.91. What is the ratio of the Area (in %) in Dominican Republic in 1993 to that in 1999?
Keep it short and to the point. 1. What is the ratio of the Area (in %) of Estonia in 1993 to that in 1999?
Your answer should be very brief. 0.94. What is the ratio of the Area (in %) of Middle East & North Africa (developing only) in 1993 to that in 2000?
Your response must be concise. 0.94. What is the ratio of the Area (in %) of Burundi in 1993 to that in 2000?
Provide a short and direct response. 0.87. What is the ratio of the Area (in %) of Estonia in 1993 to that in 2000?
Your answer should be very brief. 1.04. What is the ratio of the Area (in %) in Middle East & North Africa (developing only) in 1994 to that in 1995?
Your answer should be compact. 0.98. What is the ratio of the Area (in %) of Dominican Republic in 1994 to that in 1995?
Offer a terse response. 1. What is the ratio of the Area (in %) in Middle East & North Africa (developing only) in 1994 to that in 1996?
Give a very brief answer. 0.9. What is the ratio of the Area (in %) in Burundi in 1994 to that in 1996?
Give a very brief answer. 0.91. What is the ratio of the Area (in %) in Estonia in 1994 to that in 1996?
Ensure brevity in your answer.  0.98. What is the ratio of the Area (in %) in Middle East & North Africa (developing only) in 1994 to that in 1997?
Offer a very short reply. 0.9. What is the ratio of the Area (in %) in Burundi in 1994 to that in 1997?
Keep it short and to the point. 0.91. What is the ratio of the Area (in %) of Dominican Republic in 1994 to that in 1997?
Your response must be concise. 1. What is the ratio of the Area (in %) in Estonia in 1994 to that in 1997?
Your response must be concise. 0.98. What is the ratio of the Area (in %) of Middle East & North Africa (developing only) in 1994 to that in 1998?
Your response must be concise. 0.89. What is the ratio of the Area (in %) of Burundi in 1994 to that in 1998?
Provide a short and direct response. 0.91. What is the ratio of the Area (in %) in Dominican Republic in 1994 to that in 1998?
Make the answer very short. 1. What is the ratio of the Area (in %) of Estonia in 1994 to that in 1998?
Offer a terse response. 0.96. What is the ratio of the Area (in %) of Middle East & North Africa (developing only) in 1994 to that in 1999?
Keep it short and to the point. 0.89. What is the ratio of the Area (in %) of Burundi in 1994 to that in 1999?
Offer a terse response. 0.91. What is the ratio of the Area (in %) of Dominican Republic in 1994 to that in 1999?
Your answer should be very brief. 1. What is the ratio of the Area (in %) in Estonia in 1994 to that in 1999?
Your response must be concise. 0.96. What is the ratio of the Area (in %) in Middle East & North Africa (developing only) in 1994 to that in 2000?
Your response must be concise. 0.89. What is the ratio of the Area (in %) in Burundi in 1994 to that in 2000?
Make the answer very short. 0.87. What is the ratio of the Area (in %) of Dominican Republic in 1994 to that in 2000?
Ensure brevity in your answer.  1. What is the ratio of the Area (in %) in Estonia in 1994 to that in 2000?
Your answer should be very brief. 1.06. What is the ratio of the Area (in %) in Middle East & North Africa (developing only) in 1995 to that in 1996?
Your answer should be compact. 0.91. What is the ratio of the Area (in %) of Burundi in 1995 to that in 1996?
Your response must be concise. 0.91. What is the ratio of the Area (in %) in Estonia in 1995 to that in 1996?
Keep it short and to the point. 0.99. What is the ratio of the Area (in %) of Middle East & North Africa (developing only) in 1995 to that in 1997?
Offer a terse response. 0.91. What is the ratio of the Area (in %) in Burundi in 1995 to that in 1997?
Provide a succinct answer. 0.91. What is the ratio of the Area (in %) of Estonia in 1995 to that in 1997?
Provide a succinct answer. 0.98. What is the ratio of the Area (in %) in Middle East & North Africa (developing only) in 1995 to that in 1998?
Make the answer very short. 0.9. What is the ratio of the Area (in %) in Burundi in 1995 to that in 1998?
Provide a succinct answer. 0.91. What is the ratio of the Area (in %) in Estonia in 1995 to that in 1998?
Keep it short and to the point. 0.96. What is the ratio of the Area (in %) of Middle East & North Africa (developing only) in 1995 to that in 1999?
Provide a succinct answer. 0.9. What is the ratio of the Area (in %) in Burundi in 1995 to that in 1999?
Keep it short and to the point. 0.91. What is the ratio of the Area (in %) in Dominican Republic in 1995 to that in 1999?
Your response must be concise. 1. What is the ratio of the Area (in %) of Estonia in 1995 to that in 1999?
Ensure brevity in your answer.  0.96. What is the ratio of the Area (in %) of Middle East & North Africa (developing only) in 1995 to that in 2000?
Give a very brief answer. 0.9. What is the ratio of the Area (in %) of Burundi in 1995 to that in 2000?
Give a very brief answer. 0.87. What is the ratio of the Area (in %) of Estonia in 1995 to that in 2000?
Give a very brief answer. 1.07. What is the ratio of the Area (in %) of Middle East & North Africa (developing only) in 1996 to that in 1997?
Offer a very short reply. 1. What is the ratio of the Area (in %) of Dominican Republic in 1996 to that in 1997?
Your answer should be compact. 1. What is the ratio of the Area (in %) in Burundi in 1996 to that in 1998?
Your response must be concise. 1. What is the ratio of the Area (in %) in Estonia in 1996 to that in 1998?
Provide a short and direct response. 0.98. What is the ratio of the Area (in %) in Middle East & North Africa (developing only) in 1996 to that in 1999?
Provide a succinct answer. 0.99. What is the ratio of the Area (in %) of Estonia in 1996 to that in 1999?
Ensure brevity in your answer.  0.98. What is the ratio of the Area (in %) in Burundi in 1996 to that in 2000?
Offer a very short reply. 0.96. What is the ratio of the Area (in %) of Dominican Republic in 1996 to that in 2000?
Your response must be concise. 1. What is the ratio of the Area (in %) of Estonia in 1996 to that in 2000?
Offer a very short reply. 1.08. What is the ratio of the Area (in %) in Middle East & North Africa (developing only) in 1997 to that in 1998?
Ensure brevity in your answer.  0.99. What is the ratio of the Area (in %) of Burundi in 1997 to that in 1998?
Your answer should be very brief. 1. What is the ratio of the Area (in %) of Dominican Republic in 1997 to that in 1998?
Provide a short and direct response. 1. What is the ratio of the Area (in %) of Estonia in 1997 to that in 1998?
Ensure brevity in your answer.  0.98. What is the ratio of the Area (in %) in Middle East & North Africa (developing only) in 1997 to that in 1999?
Offer a terse response. 0.99. What is the ratio of the Area (in %) in Dominican Republic in 1997 to that in 1999?
Give a very brief answer. 1. What is the ratio of the Area (in %) of Estonia in 1997 to that in 1999?
Your answer should be very brief. 0.98. What is the ratio of the Area (in %) in Burundi in 1997 to that in 2000?
Your answer should be very brief. 0.96. What is the ratio of the Area (in %) in Dominican Republic in 1997 to that in 2000?
Make the answer very short. 1. What is the ratio of the Area (in %) in Estonia in 1997 to that in 2000?
Provide a short and direct response. 1.09. What is the ratio of the Area (in %) of Middle East & North Africa (developing only) in 1998 to that in 1999?
Your answer should be very brief. 1. What is the ratio of the Area (in %) of Dominican Republic in 1998 to that in 1999?
Provide a short and direct response. 1. What is the ratio of the Area (in %) of Burundi in 1998 to that in 2000?
Your answer should be compact. 0.96. What is the ratio of the Area (in %) in Dominican Republic in 1998 to that in 2000?
Give a very brief answer. 1. What is the ratio of the Area (in %) in Estonia in 1998 to that in 2000?
Provide a short and direct response. 1.11. What is the ratio of the Area (in %) of Burundi in 1999 to that in 2000?
Offer a very short reply. 0.96. What is the ratio of the Area (in %) of Dominican Republic in 1999 to that in 2000?
Provide a succinct answer. 1. What is the ratio of the Area (in %) of Estonia in 1999 to that in 2000?
Your answer should be very brief. 1.11. What is the difference between the highest and the second highest Area (in %) in Middle East & North Africa (developing only)?
Keep it short and to the point. 0. What is the difference between the highest and the second highest Area (in %) in Burundi?
Provide a short and direct response. 0.19. What is the difference between the highest and the second highest Area (in %) in Dominican Republic?
Provide a short and direct response. 0. What is the difference between the highest and the second highest Area (in %) in Estonia?
Give a very brief answer. 0.05. What is the difference between the highest and the lowest Area (in %) in Middle East & North Africa (developing only)?
Your response must be concise. 0.4. What is the difference between the highest and the lowest Area (in %) of Burundi?
Offer a terse response. 0.63. What is the difference between the highest and the lowest Area (in %) in Dominican Republic?
Provide a short and direct response. 0.03. What is the difference between the highest and the lowest Area (in %) of Estonia?
Make the answer very short. 1.88. 